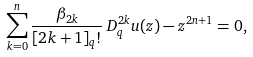Convert formula to latex. <formula><loc_0><loc_0><loc_500><loc_500>\sum _ { k = 0 } ^ { n } \frac { \beta _ { 2 k } } { [ 2 k + 1 ] _ { q } ! } \, D _ { q } ^ { 2 k } u ( z ) - z ^ { 2 n + 1 } = 0 ,</formula> 